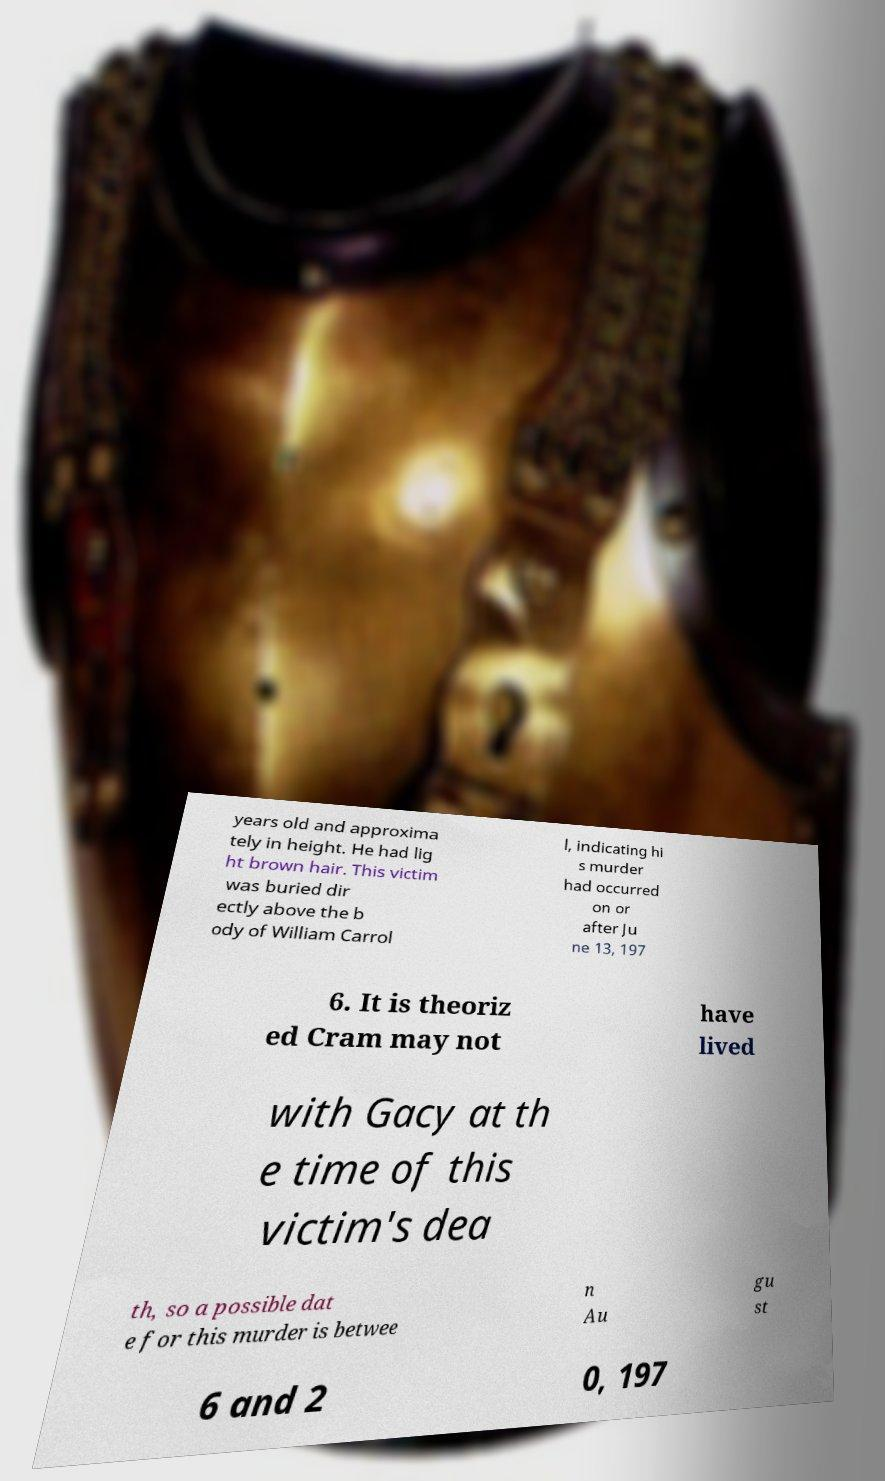Can you accurately transcribe the text from the provided image for me? years old and approxima tely in height. He had lig ht brown hair. This victim was buried dir ectly above the b ody of William Carrol l, indicating hi s murder had occurred on or after Ju ne 13, 197 6. It is theoriz ed Cram may not have lived with Gacy at th e time of this victim's dea th, so a possible dat e for this murder is betwee n Au gu st 6 and 2 0, 197 